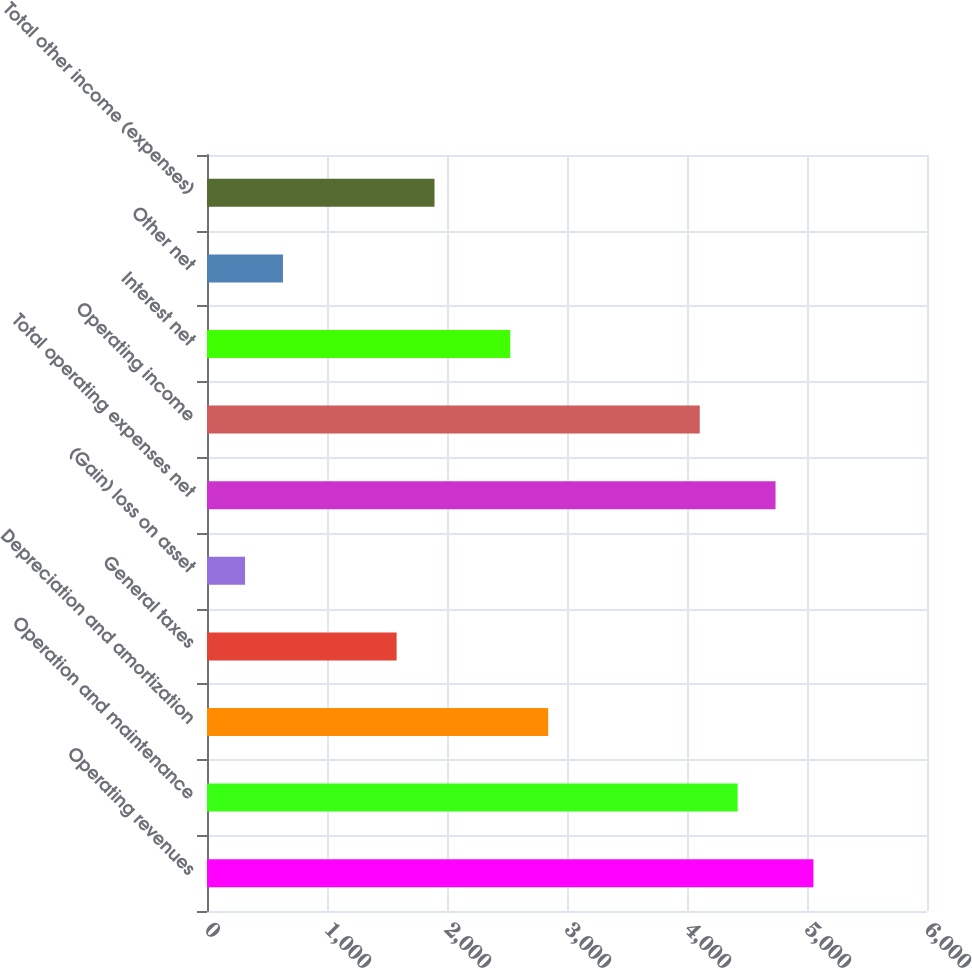<chart> <loc_0><loc_0><loc_500><loc_500><bar_chart><fcel>Operating revenues<fcel>Operation and maintenance<fcel>Depreciation and amortization<fcel>General taxes<fcel>(Gain) loss on asset<fcel>Total operating expenses net<fcel>Operating income<fcel>Interest net<fcel>Other net<fcel>Total other income (expenses)<nl><fcel>5053.52<fcel>4422<fcel>2843.2<fcel>1580.16<fcel>317.12<fcel>4737.76<fcel>4106.24<fcel>2527.44<fcel>632.88<fcel>1895.92<nl></chart> 